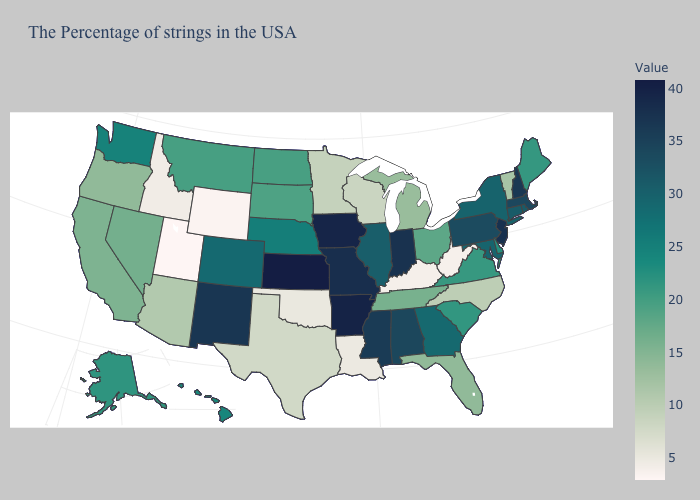Does Utah have the lowest value in the USA?
Give a very brief answer. Yes. Does Vermont have a lower value than Alaska?
Give a very brief answer. Yes. Among the states that border Nebraska , which have the lowest value?
Give a very brief answer. Wyoming. Is the legend a continuous bar?
Give a very brief answer. Yes. Which states have the lowest value in the South?
Short answer required. West Virginia. 